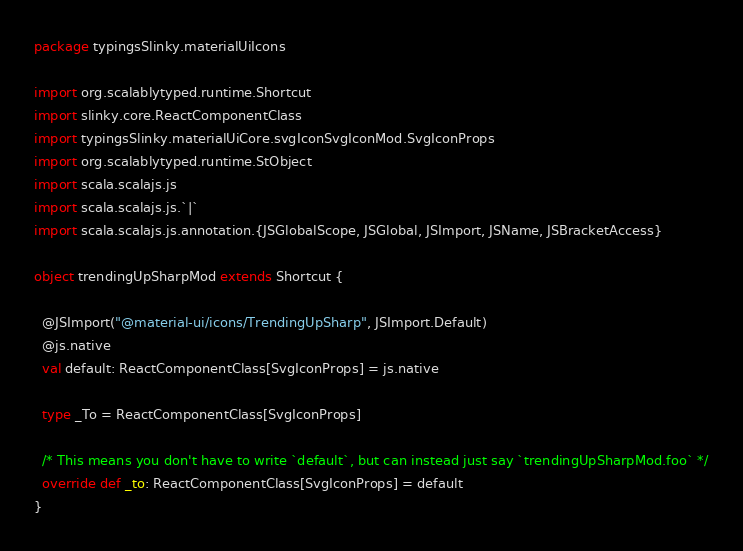Convert code to text. <code><loc_0><loc_0><loc_500><loc_500><_Scala_>package typingsSlinky.materialUiIcons

import org.scalablytyped.runtime.Shortcut
import slinky.core.ReactComponentClass
import typingsSlinky.materialUiCore.svgIconSvgIconMod.SvgIconProps
import org.scalablytyped.runtime.StObject
import scala.scalajs.js
import scala.scalajs.js.`|`
import scala.scalajs.js.annotation.{JSGlobalScope, JSGlobal, JSImport, JSName, JSBracketAccess}

object trendingUpSharpMod extends Shortcut {
  
  @JSImport("@material-ui/icons/TrendingUpSharp", JSImport.Default)
  @js.native
  val default: ReactComponentClass[SvgIconProps] = js.native
  
  type _To = ReactComponentClass[SvgIconProps]
  
  /* This means you don't have to write `default`, but can instead just say `trendingUpSharpMod.foo` */
  override def _to: ReactComponentClass[SvgIconProps] = default
}
</code> 